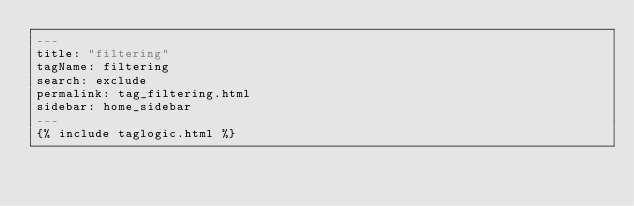<code> <loc_0><loc_0><loc_500><loc_500><_YAML_>---
title: "filtering"
tagName: filtering
search: exclude
permalink: tag_filtering.html
sidebar: home_sidebar
---
{% include taglogic.html %}
</code> 